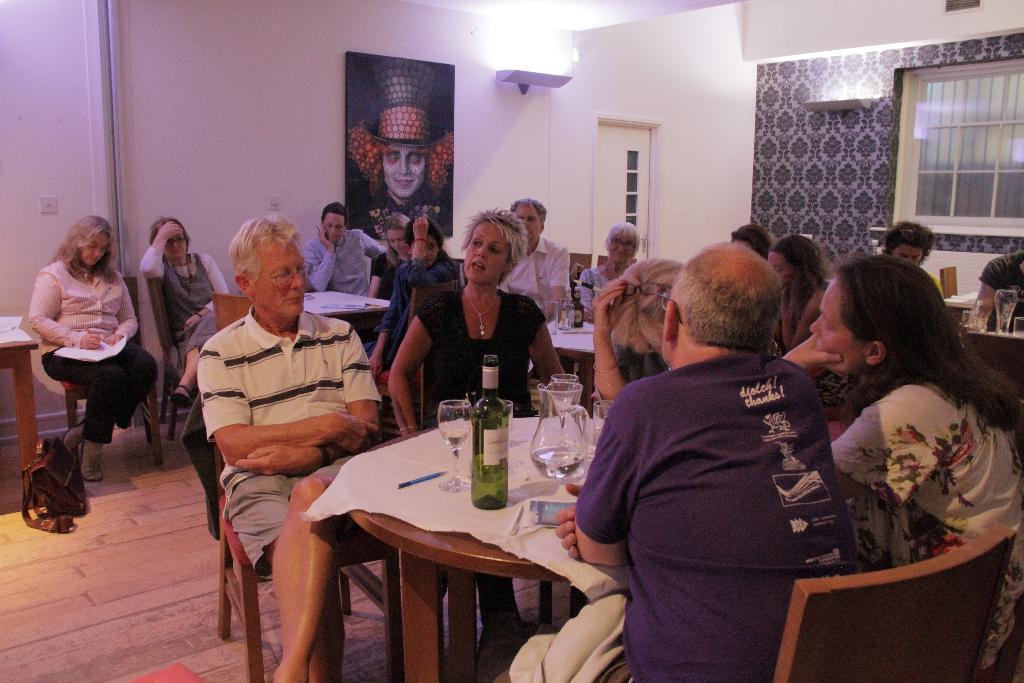Can you describe this image briefly? There are group of sitting on the chairs. this is a table covered with a cloth. Here are a wine glass,jug and a bottle placed on the table. I can see a bag kept on the floor. This is a photo frame attached to the wall,and here is a door with a door handle. This looks like a window. 